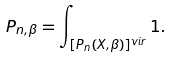<formula> <loc_0><loc_0><loc_500><loc_500>P _ { n , \beta } = \int _ { [ P _ { n } ( X , \beta ) ] ^ { v i r } } 1 .</formula> 